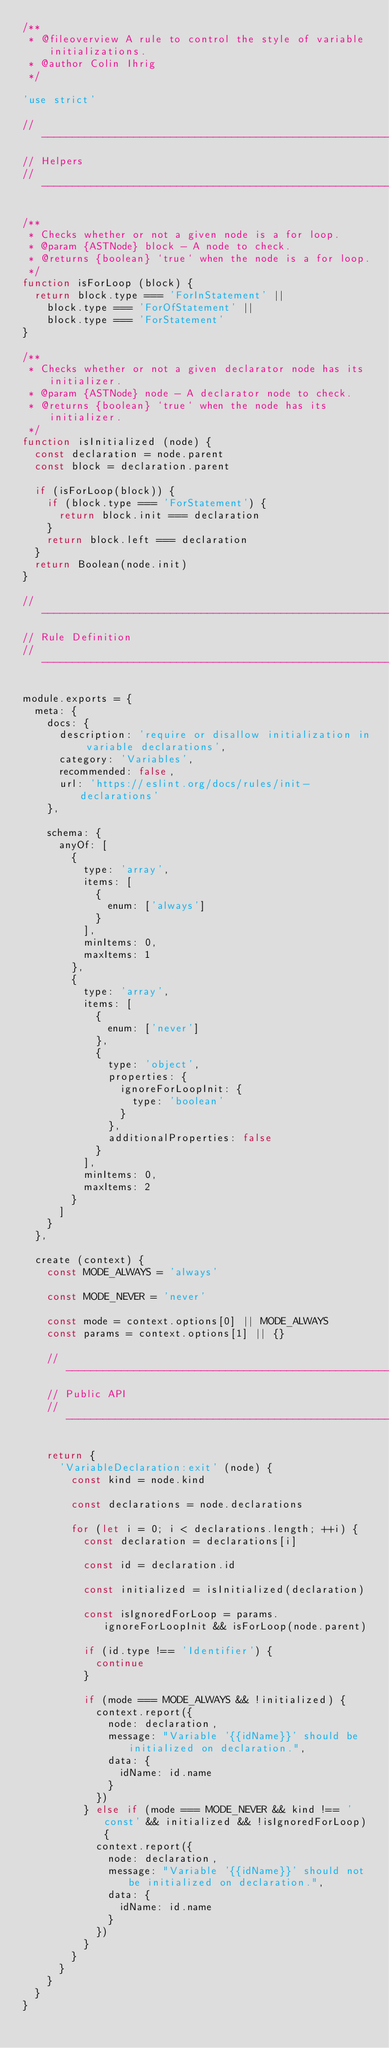<code> <loc_0><loc_0><loc_500><loc_500><_JavaScript_>/**
 * @fileoverview A rule to control the style of variable initializations.
 * @author Colin Ihrig
 */

'use strict'

// ------------------------------------------------------------------------------
// Helpers
// ------------------------------------------------------------------------------

/**
 * Checks whether or not a given node is a for loop.
 * @param {ASTNode} block - A node to check.
 * @returns {boolean} `true` when the node is a for loop.
 */
function isForLoop (block) {
  return block.type === 'ForInStatement' ||
    block.type === 'ForOfStatement' ||
    block.type === 'ForStatement'
}

/**
 * Checks whether or not a given declarator node has its initializer.
 * @param {ASTNode} node - A declarator node to check.
 * @returns {boolean} `true` when the node has its initializer.
 */
function isInitialized (node) {
  const declaration = node.parent
  const block = declaration.parent

  if (isForLoop(block)) {
    if (block.type === 'ForStatement') {
      return block.init === declaration
    }
    return block.left === declaration
  }
  return Boolean(node.init)
}

// ------------------------------------------------------------------------------
// Rule Definition
// ------------------------------------------------------------------------------

module.exports = {
  meta: {
    docs: {
      description: 'require or disallow initialization in variable declarations',
      category: 'Variables',
      recommended: false,
      url: 'https://eslint.org/docs/rules/init-declarations'
    },

    schema: {
      anyOf: [
        {
          type: 'array',
          items: [
            {
              enum: ['always']
            }
          ],
          minItems: 0,
          maxItems: 1
        },
        {
          type: 'array',
          items: [
            {
              enum: ['never']
            },
            {
              type: 'object',
              properties: {
                ignoreForLoopInit: {
                  type: 'boolean'
                }
              },
              additionalProperties: false
            }
          ],
          minItems: 0,
          maxItems: 2
        }
      ]
    }
  },

  create (context) {
    const MODE_ALWAYS = 'always'

    const MODE_NEVER = 'never'

    const mode = context.options[0] || MODE_ALWAYS
    const params = context.options[1] || {}

    // --------------------------------------------------------------------------
    // Public API
    // --------------------------------------------------------------------------

    return {
      'VariableDeclaration:exit' (node) {
        const kind = node.kind

        const declarations = node.declarations

        for (let i = 0; i < declarations.length; ++i) {
          const declaration = declarations[i]

          const id = declaration.id

          const initialized = isInitialized(declaration)

          const isIgnoredForLoop = params.ignoreForLoopInit && isForLoop(node.parent)

          if (id.type !== 'Identifier') {
            continue
          }

          if (mode === MODE_ALWAYS && !initialized) {
            context.report({
              node: declaration,
              message: "Variable '{{idName}}' should be initialized on declaration.",
              data: {
                idName: id.name
              }
            })
          } else if (mode === MODE_NEVER && kind !== 'const' && initialized && !isIgnoredForLoop) {
            context.report({
              node: declaration,
              message: "Variable '{{idName}}' should not be initialized on declaration.",
              data: {
                idName: id.name
              }
            })
          }
        }
      }
    }
  }
}
</code> 